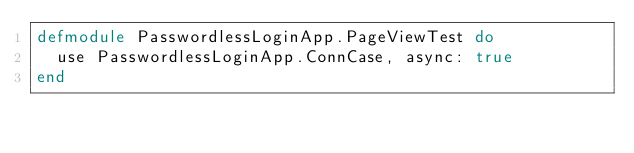<code> <loc_0><loc_0><loc_500><loc_500><_Elixir_>defmodule PasswordlessLoginApp.PageViewTest do
  use PasswordlessLoginApp.ConnCase, async: true
end
</code> 